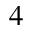<formula> <loc_0><loc_0><loc_500><loc_500>^ { 4 }</formula> 